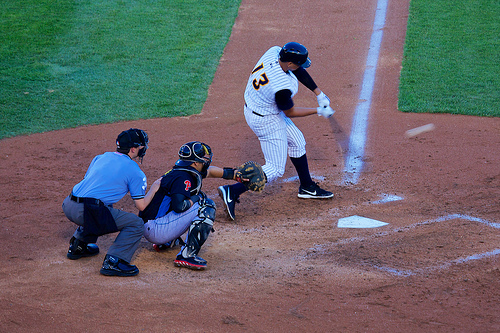What does the stance of the player at bat suggest about his technique? The stancesuggests a powerful, aggressive batting technique. The player is mid-swing, with hips rotated and weight transferring forward, indicating a full commitment to hitting the ball with as much power as possible. 